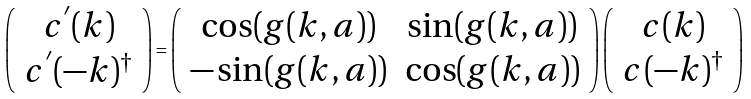<formula> <loc_0><loc_0><loc_500><loc_500>\left ( \begin{array} { c } c ^ { ^ { \prime } } ( k ) \\ c ^ { ^ { \prime } } ( - k ) ^ { \dag } \end{array} \right ) = \left ( \begin{array} { c c } \cos ( g ( k , a ) ) & \sin ( g ( k , a ) ) \\ - \sin ( g ( k , a ) ) & \cos ( g ( k , a ) ) \end{array} \right ) \left ( \begin{array} { c } c ( k ) \\ c ( - k ) ^ { \dag } \end{array} \right )</formula> 